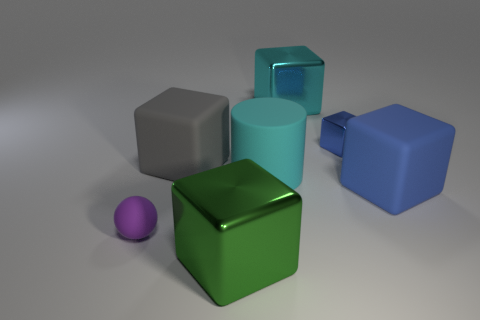Subtract 2 blocks. How many blocks are left? 3 Subtract all gray blocks. How many blocks are left? 4 Subtract all cyan blocks. How many blocks are left? 4 Subtract all cyan cubes. Subtract all blue cylinders. How many cubes are left? 4 Add 2 cyan metal cubes. How many objects exist? 9 Subtract all cylinders. How many objects are left? 6 Add 3 small rubber objects. How many small rubber objects are left? 4 Add 3 metallic blocks. How many metallic blocks exist? 6 Subtract 1 green cubes. How many objects are left? 6 Subtract all large purple matte spheres. Subtract all rubber spheres. How many objects are left? 6 